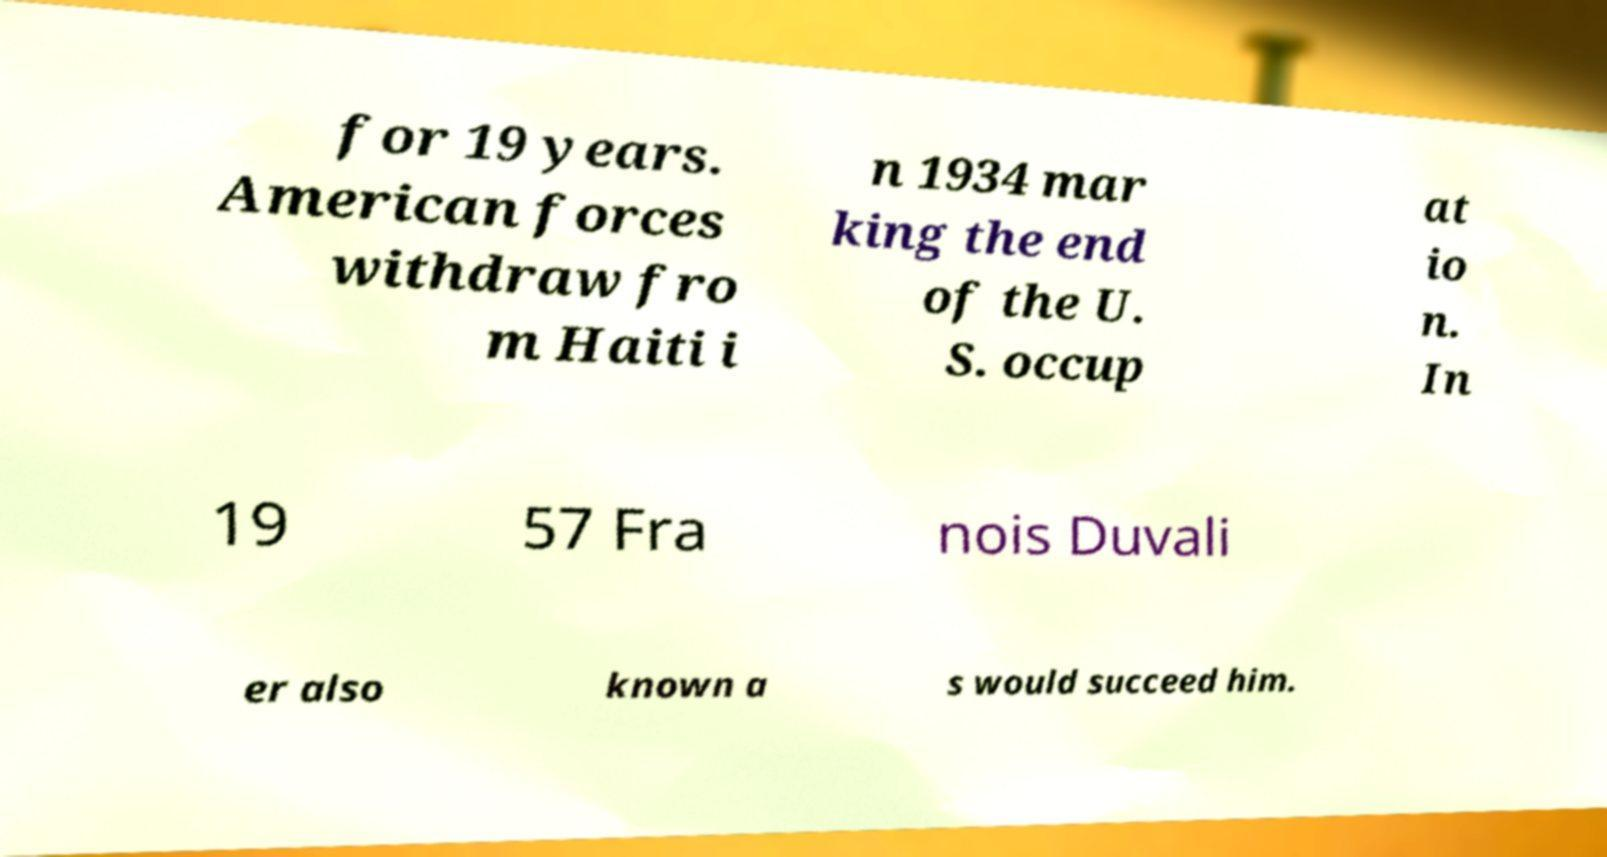There's text embedded in this image that I need extracted. Can you transcribe it verbatim? for 19 years. American forces withdraw fro m Haiti i n 1934 mar king the end of the U. S. occup at io n. In 19 57 Fra nois Duvali er also known a s would succeed him. 